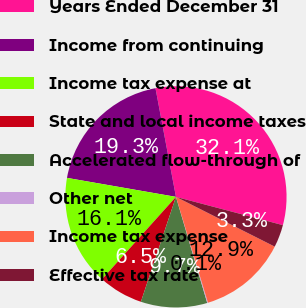Convert chart to OTSL. <chart><loc_0><loc_0><loc_500><loc_500><pie_chart><fcel>Years Ended December 31<fcel>Income from continuing<fcel>Income tax expense at<fcel>State and local income taxes<fcel>Accelerated flow-through of<fcel>Other net<fcel>Income tax expense<fcel>Effective tax rate<nl><fcel>32.08%<fcel>19.29%<fcel>16.1%<fcel>6.51%<fcel>9.7%<fcel>0.11%<fcel>12.9%<fcel>3.31%<nl></chart> 